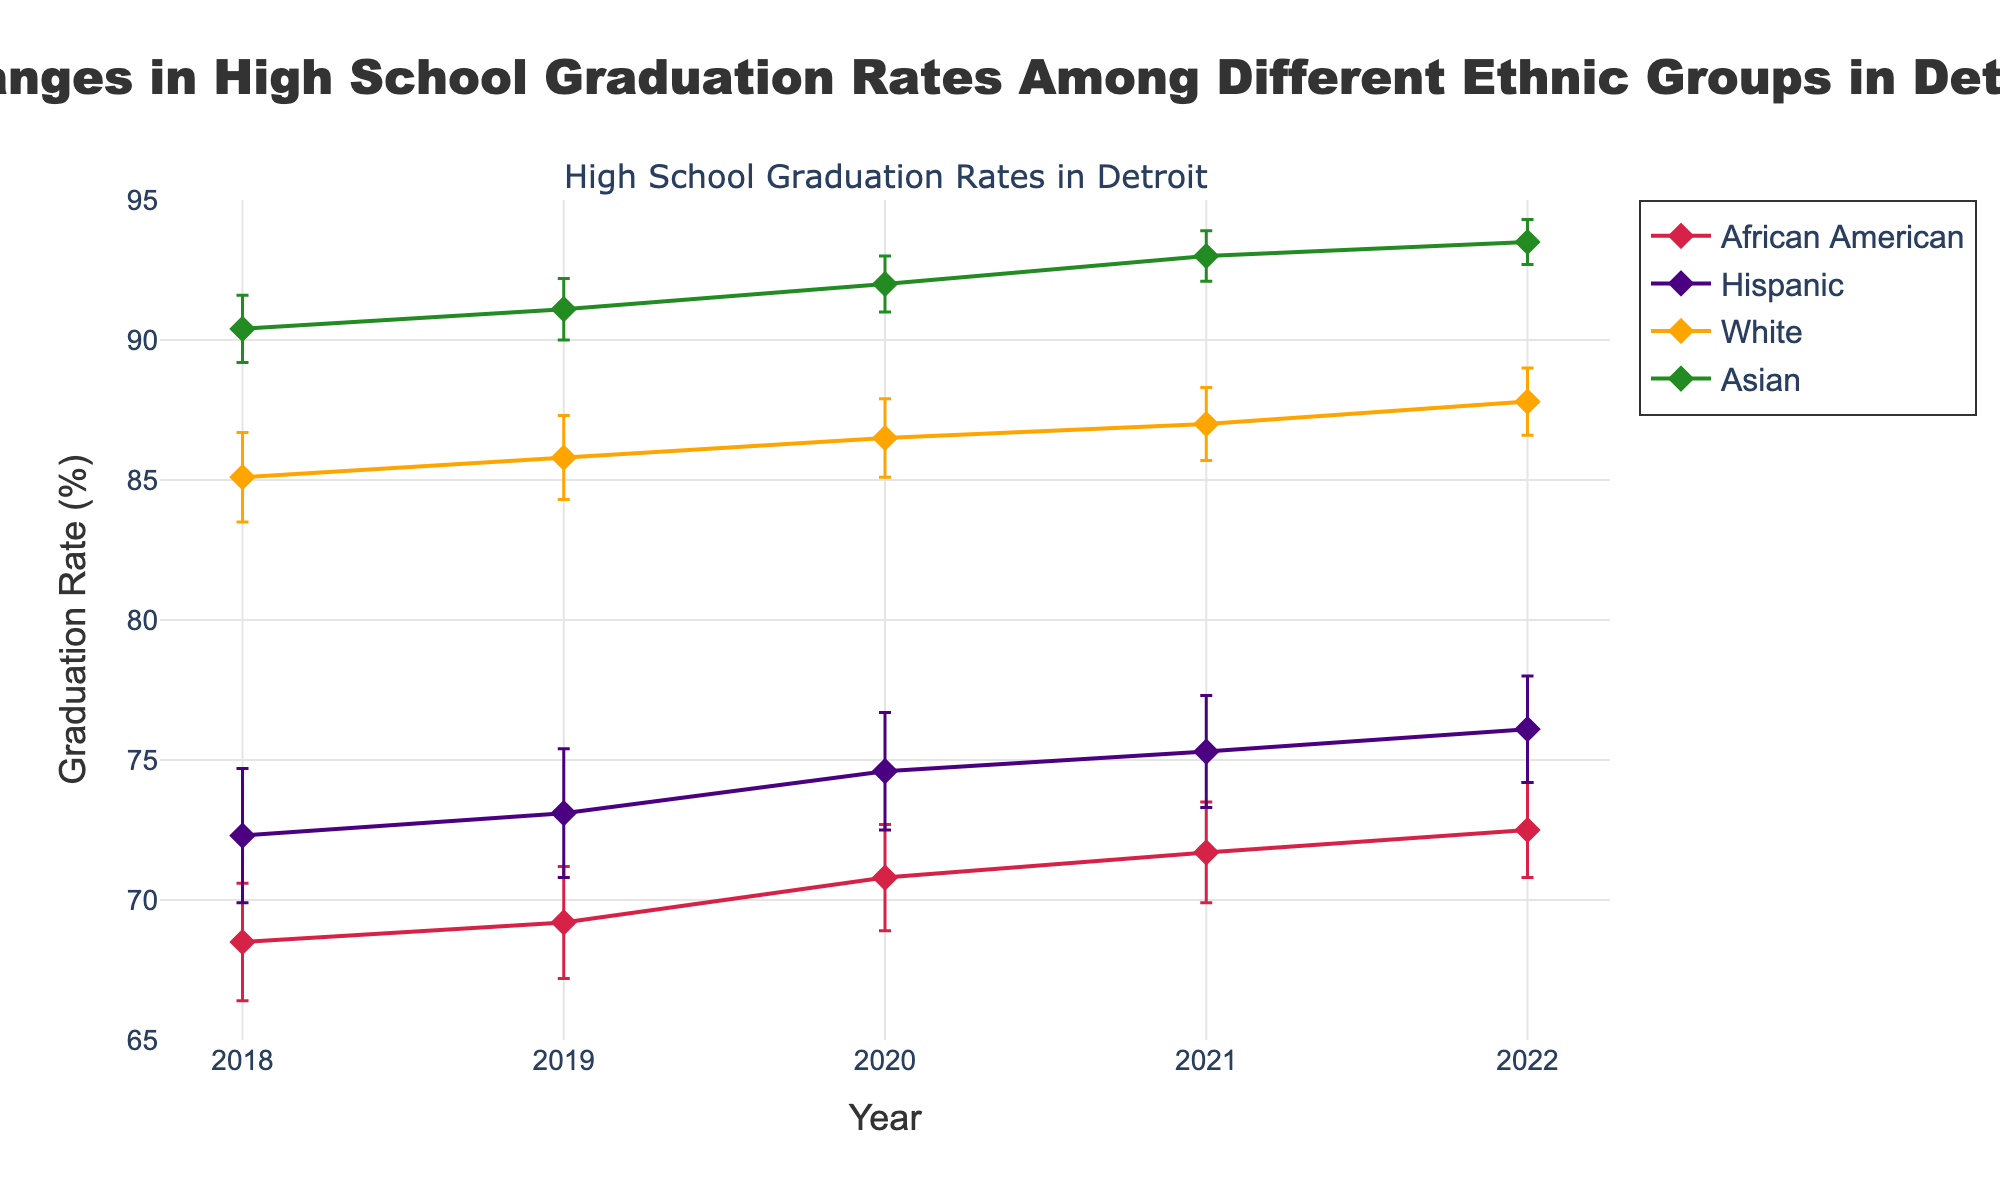What is the title of the plot? The title is usually located at the top of the plot. In this case, the title is "Changes in High School Graduation Rates Among Different Ethnic Groups in Detroit," which clearly indicates what the plot is about.
Answer: Changes in High School Graduation Rates Among Different Ethnic Groups in Detroit What are the y-axis values for the African American group in 2020? To find this, look at the line representing the African American group and find the data point corresponding to the year 2020, which is an upward trend. The value is 70.8.
Answer: 70.8 What color represents the Hispanic group in the plot? Each ethnic group is represented by a different color. The Hispanic group is represented in the color that matches with their data points, which is purple (#4B0082).
Answer: purple Which ethnic group shows the highest graduation rate in 2022? To determine this, look for the highest data point in 2022. This point is for the Asian group, which has the highest graduation rate in that year.
Answer: Asian What is the overall trend for the graduation rates of the African American group from 2018 to 2022? Observing the line representing the African American group, it shows a steady increase from 68.5% in 2018 to 72.5% in 2022.
Answer: Increasing What is the difference in graduation rates between the African American and White groups in 2021? Find the rates for both groups in 2021 and subtract the African American rate from the White rate: 87.0% (White) - 71.7% (African American) = 15.3%.
Answer: 15.3% Which ethnic group has shown the most consistent improvement over the 5 years? Examine the error bars and the overall trend for consistency. The Asian group shows a steady and consistent improvement with the smallest error margins.
Answer: Asian Compare the graduation rate change from 2018 to 2022 for the Hispanic and White groups. Which group had a larger increase? Calculate the increase for both groups from 2018 to 2022: Hispanic: 76.1% - 72.3% = 3.8%, White: 87.8% - 85.1% = 2.7%. The Hispanic group had a larger increase.
Answer: Hispanic What is the graduation rate for the Asian group in 2019, and what is the error margin for this data point? Locate the data point for the Asian group in 2019. The graduation rate is 91.1% and the error margin is 1.1%.
Answer: 91.1% with an error margin of 1.1% 